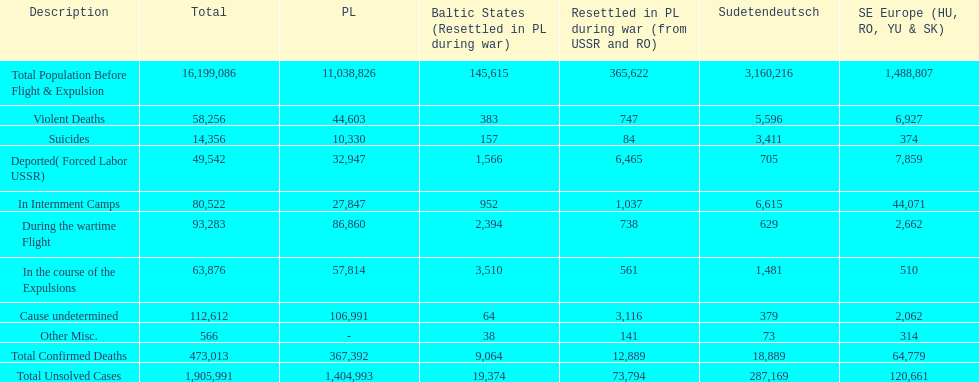What is the difference between suicides in poland and sudetendeutsch? 6919. 